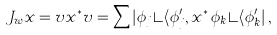<formula> <loc_0><loc_0><loc_500><loc_500>J _ { w } x = v x ^ { * } v = \sum | \phi _ { j } \rangle \langle \phi ^ { \prime } _ { j } , x ^ { * } \, \phi _ { k } \rangle \langle \phi ^ { \prime } _ { k } | \, ,</formula> 